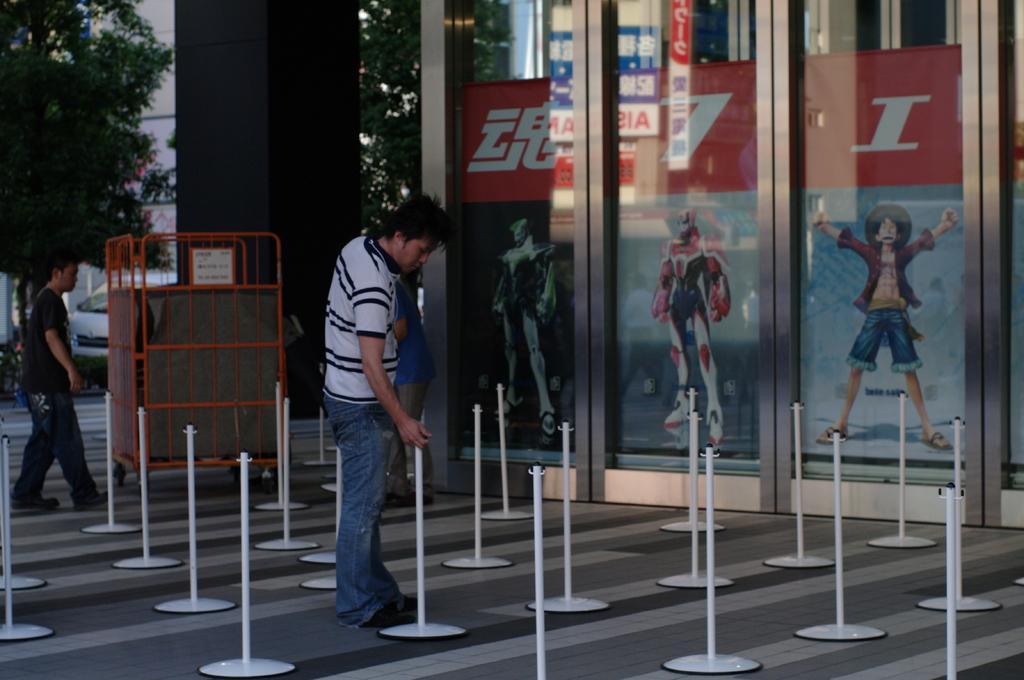How would you summarize this image in a sentence or two? There is a complex and in front of the complex there are many small poles. A person is standing beside one of the poles. Behind them there is a black square pillar and behind the pillar there is a vehicle and some trees. 